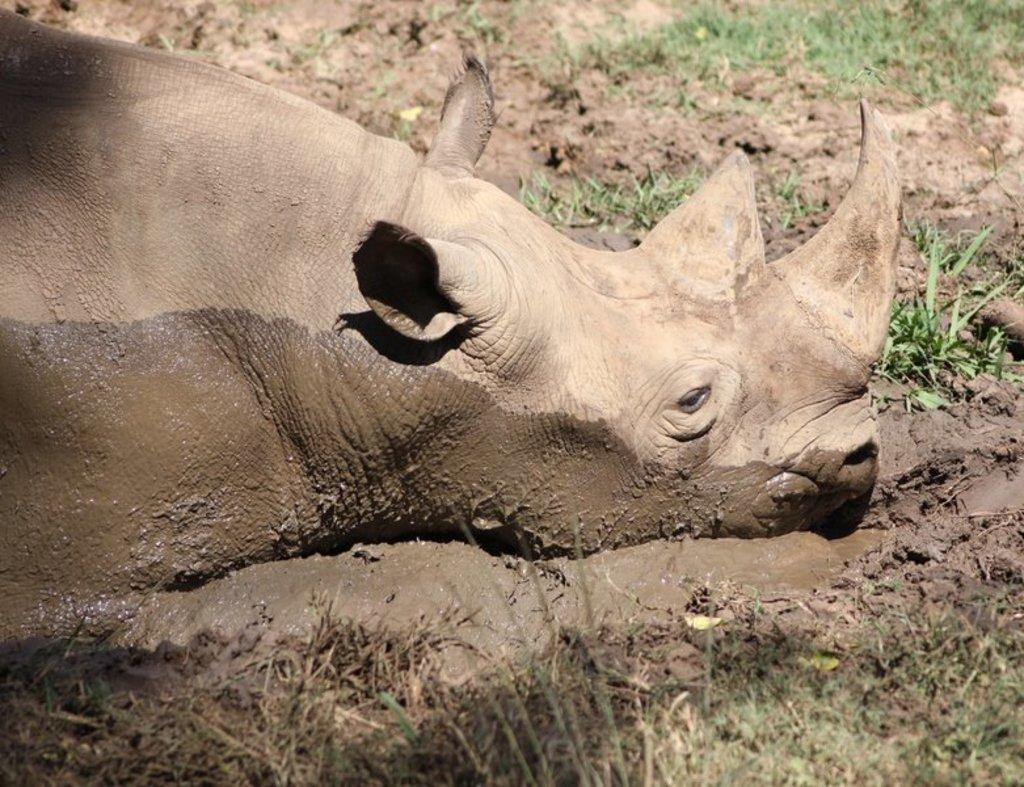What animal is the main subject of the image? There is a hippopotamus in the image. What is the environment in which the hippopotamus is situated? The hippopotamus is in muddy water. What type of vegetation can be seen on either side of the hippopotamus? There is greenery on either side of the hippopotamus. What part of the ground is visible in the image? The ground is visible in the image. What type of lipstick is the hippopotamus wearing in the image? There is no lipstick or any indication of makeup on the hippopotamus in the image. 